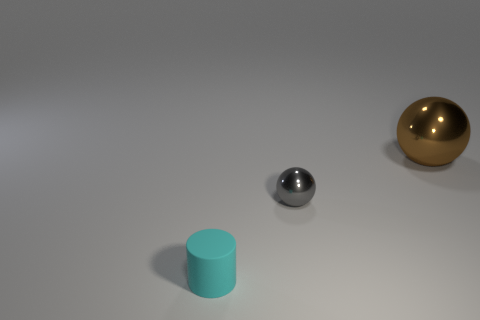Is there a small cyan matte cylinder that is on the left side of the metal thing to the right of the ball that is in front of the brown shiny sphere?
Keep it short and to the point. Yes. Are there any other things that have the same shape as the brown shiny object?
Make the answer very short. Yes. Are there any tiny balls?
Give a very brief answer. Yes. Is the small object that is right of the small matte cylinder made of the same material as the sphere that is on the right side of the small ball?
Your answer should be compact. Yes. How big is the metal ball that is on the right side of the ball on the left side of the thing on the right side of the gray metal thing?
Give a very brief answer. Large. How many cyan things are the same material as the tiny cyan cylinder?
Offer a very short reply. 0. Is the number of gray metal spheres less than the number of small gray matte balls?
Offer a terse response. No. What is the size of the other gray object that is the same shape as the big object?
Give a very brief answer. Small. Does the sphere that is on the left side of the big brown ball have the same material as the big brown ball?
Your answer should be compact. Yes. Is the big thing the same shape as the gray object?
Keep it short and to the point. Yes. 